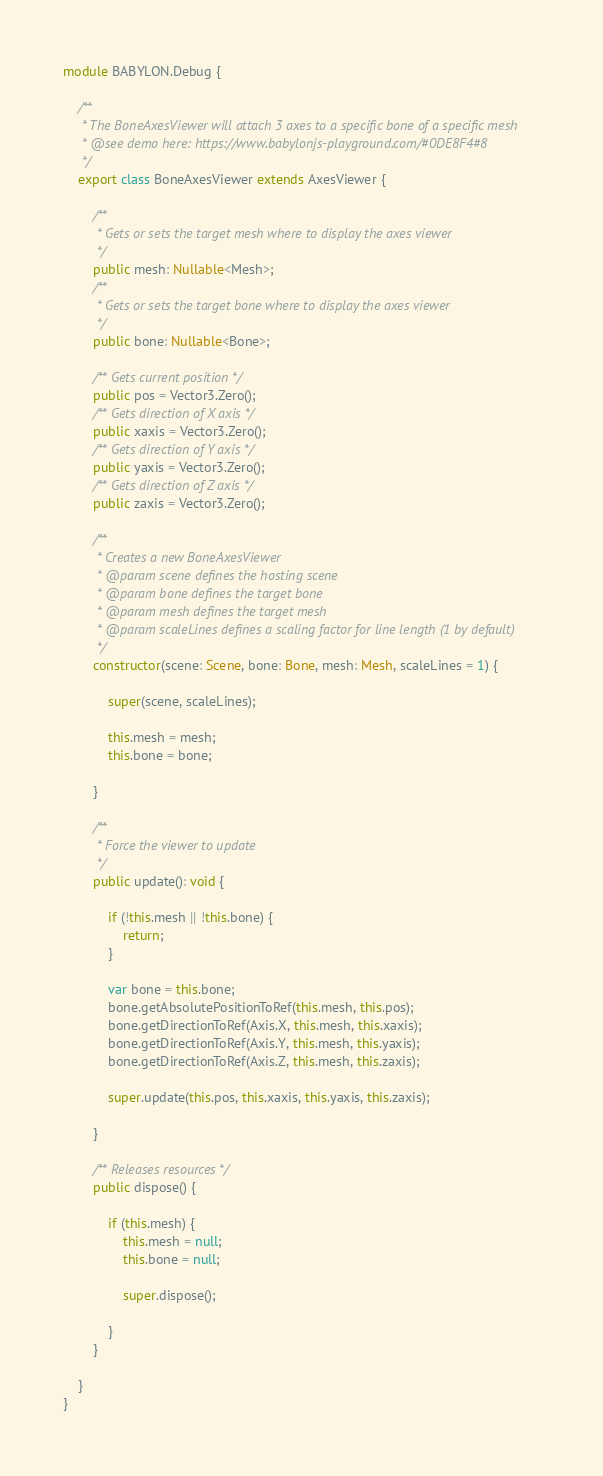<code> <loc_0><loc_0><loc_500><loc_500><_TypeScript_>module BABYLON.Debug {

    /**
     * The BoneAxesViewer will attach 3 axes to a specific bone of a specific mesh
     * @see demo here: https://www.babylonjs-playground.com/#0DE8F4#8
     */
    export class BoneAxesViewer extends AxesViewer {

        /**
         * Gets or sets the target mesh where to display the axes viewer
         */
        public mesh: Nullable<Mesh>;
        /**
         * Gets or sets the target bone where to display the axes viewer
         */
        public bone: Nullable<Bone>;

        /** Gets current position */
        public pos = Vector3.Zero();
        /** Gets direction of X axis */
        public xaxis = Vector3.Zero();
        /** Gets direction of Y axis */
        public yaxis = Vector3.Zero();
        /** Gets direction of Z axis */
        public zaxis = Vector3.Zero();

        /**
         * Creates a new BoneAxesViewer
         * @param scene defines the hosting scene
         * @param bone defines the target bone
         * @param mesh defines the target mesh
         * @param scaleLines defines a scaling factor for line length (1 by default)
         */
        constructor(scene: Scene, bone: Bone, mesh: Mesh, scaleLines = 1) {

            super(scene, scaleLines);

            this.mesh = mesh;
            this.bone = bone;

        }

        /**
         * Force the viewer to update
         */
        public update(): void {

            if (!this.mesh || !this.bone) {
                return;
            }

            var bone = this.bone;
            bone.getAbsolutePositionToRef(this.mesh, this.pos);
            bone.getDirectionToRef(Axis.X, this.mesh, this.xaxis);
            bone.getDirectionToRef(Axis.Y, this.mesh, this.yaxis);
            bone.getDirectionToRef(Axis.Z, this.mesh, this.zaxis);

            super.update(this.pos, this.xaxis, this.yaxis, this.zaxis);

        }

        /** Releases resources */
        public dispose() {

            if (this.mesh) {
                this.mesh = null;
                this.bone = null;

                super.dispose();

            }
        }

    }
}</code> 